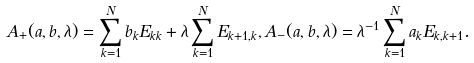<formula> <loc_0><loc_0><loc_500><loc_500>A _ { + } ( a , b , \lambda ) = \sum _ { k = 1 } ^ { N } b _ { k } E _ { k k } + \lambda \sum _ { k = 1 } ^ { N } E _ { k + 1 , k } , A _ { - } ( a , b , \lambda ) = \lambda ^ { - 1 } \sum _ { k = 1 } ^ { N } a _ { k } E _ { k , k + 1 } .</formula> 